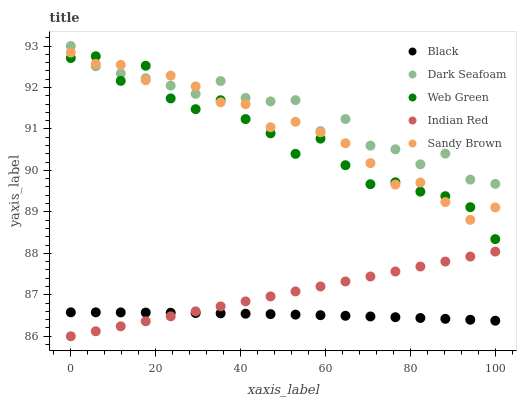Does Black have the minimum area under the curve?
Answer yes or no. Yes. Does Dark Seafoam have the maximum area under the curve?
Answer yes or no. Yes. Does Dark Seafoam have the minimum area under the curve?
Answer yes or no. No. Does Black have the maximum area under the curve?
Answer yes or no. No. Is Indian Red the smoothest?
Answer yes or no. Yes. Is Web Green the roughest?
Answer yes or no. Yes. Is Dark Seafoam the smoothest?
Answer yes or no. No. Is Dark Seafoam the roughest?
Answer yes or no. No. Does Indian Red have the lowest value?
Answer yes or no. Yes. Does Black have the lowest value?
Answer yes or no. No. Does Dark Seafoam have the highest value?
Answer yes or no. Yes. Does Black have the highest value?
Answer yes or no. No. Is Indian Red less than Dark Seafoam?
Answer yes or no. Yes. Is Dark Seafoam greater than Indian Red?
Answer yes or no. Yes. Does Black intersect Indian Red?
Answer yes or no. Yes. Is Black less than Indian Red?
Answer yes or no. No. Is Black greater than Indian Red?
Answer yes or no. No. Does Indian Red intersect Dark Seafoam?
Answer yes or no. No. 